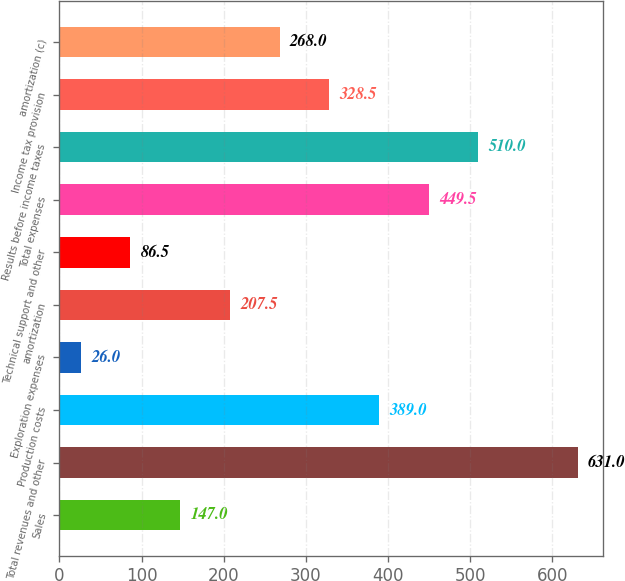Convert chart. <chart><loc_0><loc_0><loc_500><loc_500><bar_chart><fcel>Sales<fcel>Total revenues and other<fcel>Production costs<fcel>Exploration expenses<fcel>amortization<fcel>Technical support and other<fcel>Total expenses<fcel>Results before income taxes<fcel>Income tax provision<fcel>amortization (c)<nl><fcel>147<fcel>631<fcel>389<fcel>26<fcel>207.5<fcel>86.5<fcel>449.5<fcel>510<fcel>328.5<fcel>268<nl></chart> 